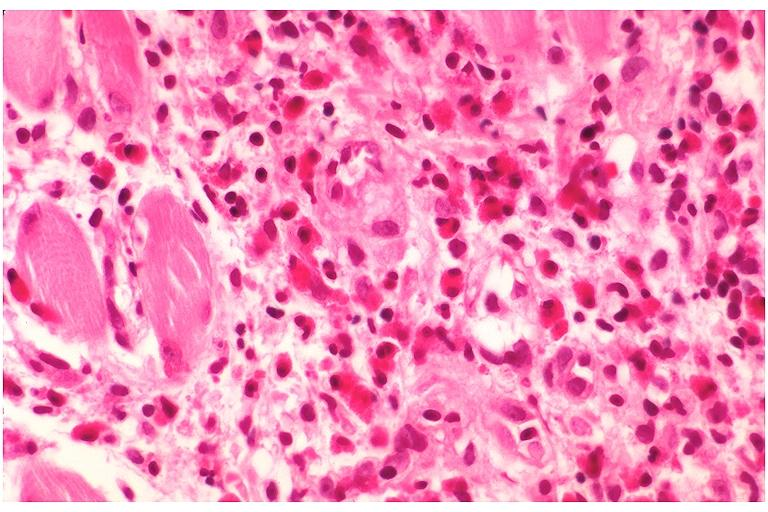does this image show langerhans cell histiocytosis eosinophilic granuloma?
Answer the question using a single word or phrase. Yes 